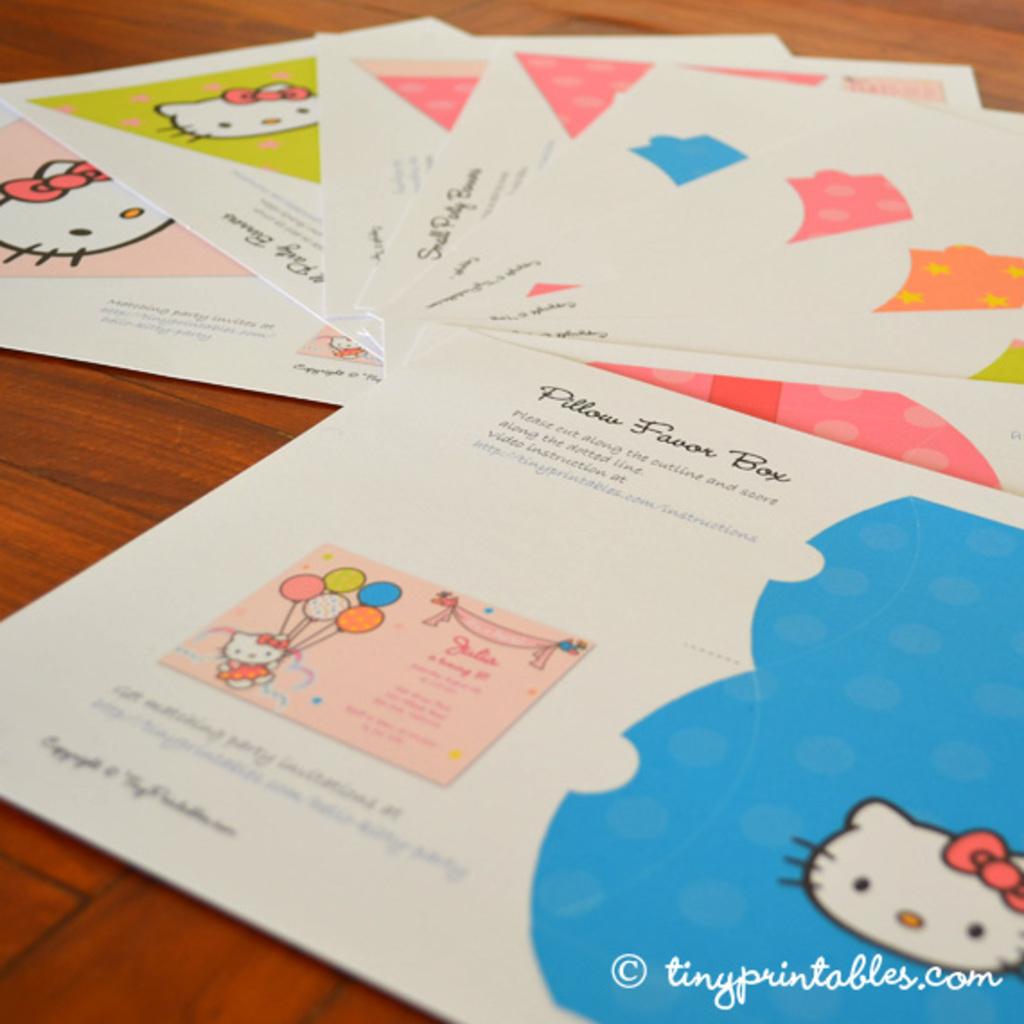Is this about a pillow favor box?
Offer a terse response. Yes. What is the website at the bottom?
Ensure brevity in your answer.  Tinyprintables.com. 